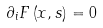<formula> <loc_0><loc_0><loc_500><loc_500>\partial _ { i } F \left ( x , s \right ) = 0</formula> 